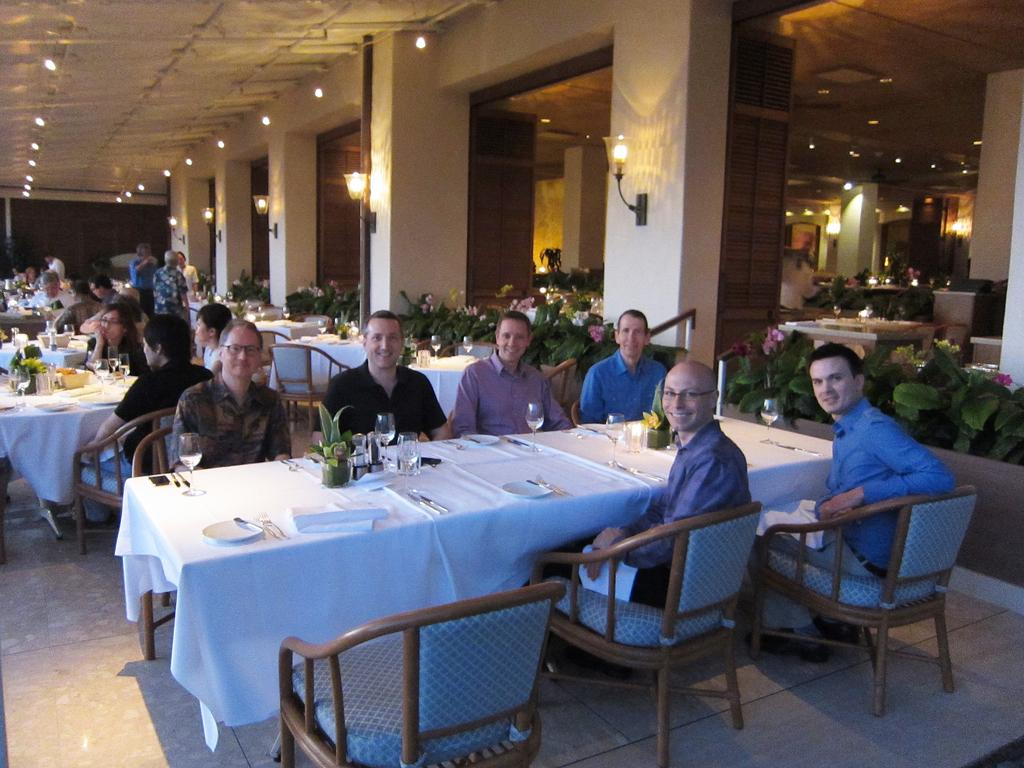What type of furniture is present in the room? There are tables and chairs in the room. What can be found on the tables? There are glasses and plates on the table. Where are the plants located in the room? The plants are at the right side of the room. What is used to illuminate the room? There are lights in the room. What type of birds can be seen flying around the room? There are no birds visible in the room; the image only shows tables, chairs, glasses, plates, plants, and lights. 